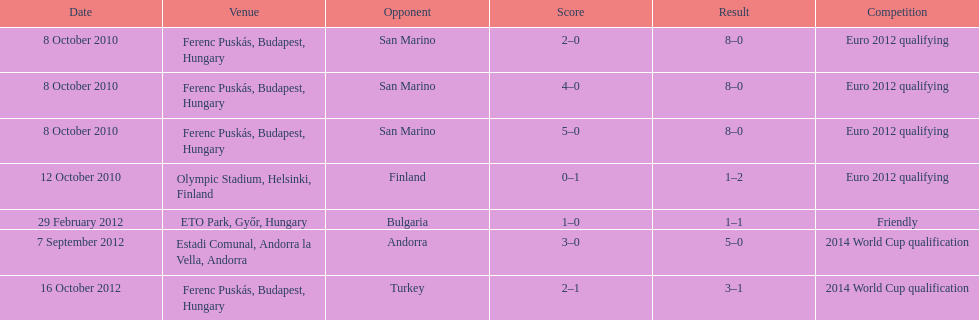When did ádám szalai make his first international goal? 8 October 2010. Help me parse the entirety of this table. {'header': ['Date', 'Venue', 'Opponent', 'Score', 'Result', 'Competition'], 'rows': [['8 October 2010', 'Ferenc Puskás, Budapest, Hungary', 'San Marino', '2–0', '8–0', 'Euro 2012 qualifying'], ['8 October 2010', 'Ferenc Puskás, Budapest, Hungary', 'San Marino', '4–0', '8–0', 'Euro 2012 qualifying'], ['8 October 2010', 'Ferenc Puskás, Budapest, Hungary', 'San Marino', '5–0', '8–0', 'Euro 2012 qualifying'], ['12 October 2010', 'Olympic Stadium, Helsinki, Finland', 'Finland', '0–1', '1–2', 'Euro 2012 qualifying'], ['29 February 2012', 'ETO Park, Győr, Hungary', 'Bulgaria', '1–0', '1–1', 'Friendly'], ['7 September 2012', 'Estadi Comunal, Andorra la Vella, Andorra', 'Andorra', '3–0', '5–0', '2014 World Cup qualification'], ['16 October 2012', 'Ferenc Puskás, Budapest, Hungary', 'Turkey', '2–1', '3–1', '2014 World Cup qualification']]} 